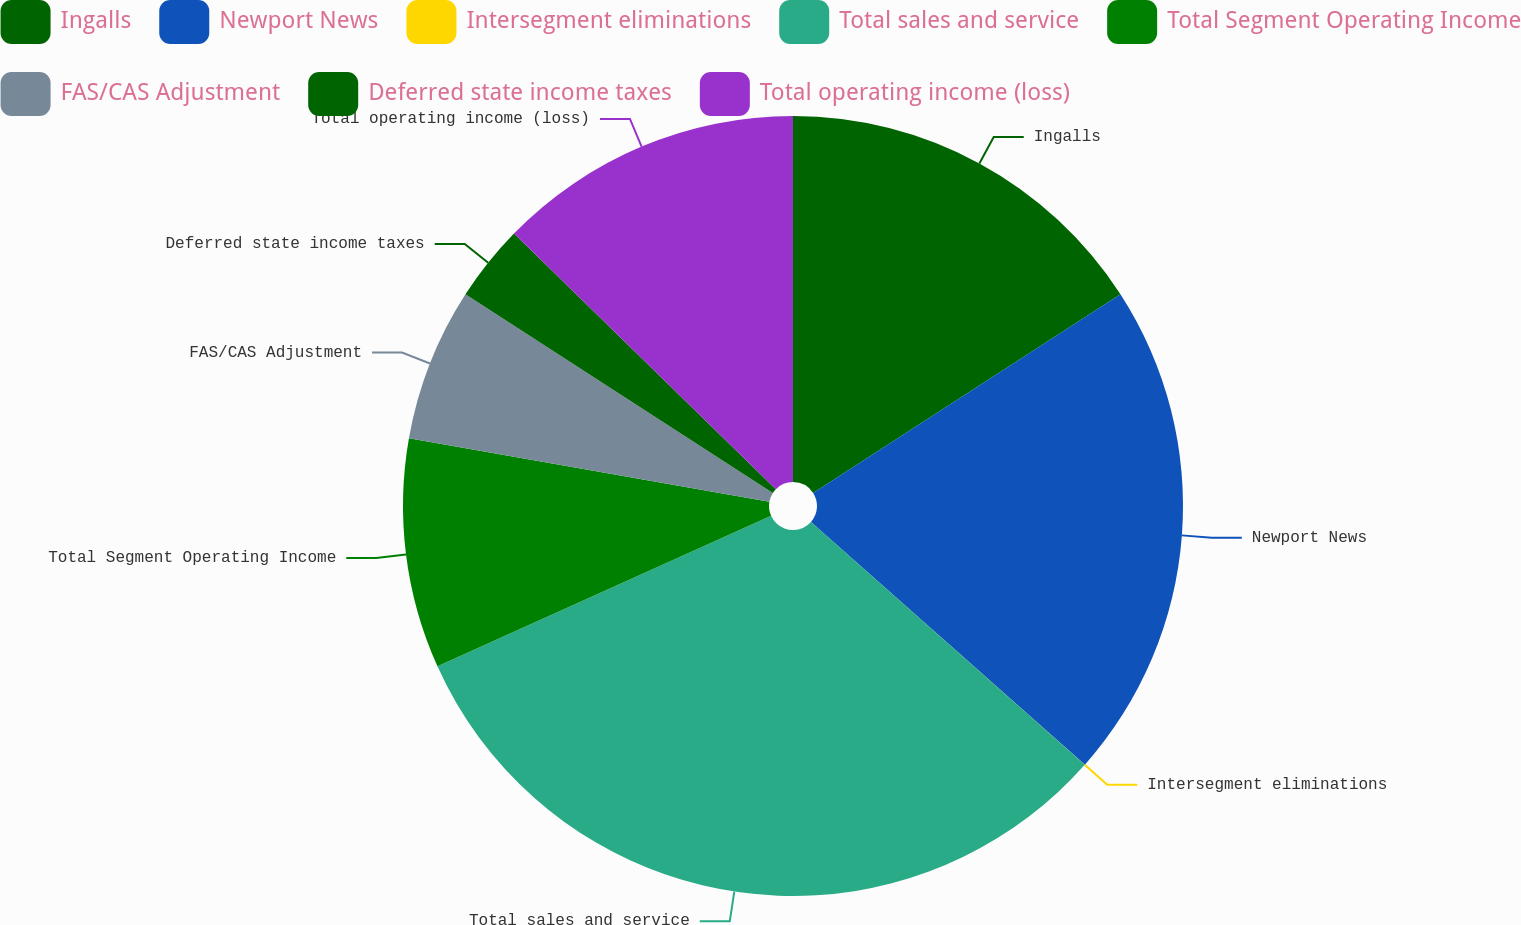<chart> <loc_0><loc_0><loc_500><loc_500><pie_chart><fcel>Ingalls<fcel>Newport News<fcel>Intersegment eliminations<fcel>Total sales and service<fcel>Total Segment Operating Income<fcel>FAS/CAS Adjustment<fcel>Deferred state income taxes<fcel>Total operating income (loss)<nl><fcel>15.86%<fcel>20.68%<fcel>0.01%<fcel>31.71%<fcel>9.52%<fcel>6.35%<fcel>3.18%<fcel>12.69%<nl></chart> 